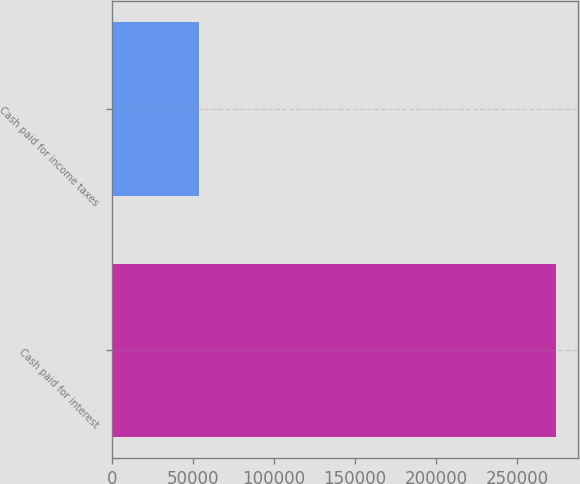Convert chart to OTSL. <chart><loc_0><loc_0><loc_500><loc_500><bar_chart><fcel>Cash paid for interest<fcel>Cash paid for income taxes<nl><fcel>274234<fcel>53909<nl></chart> 